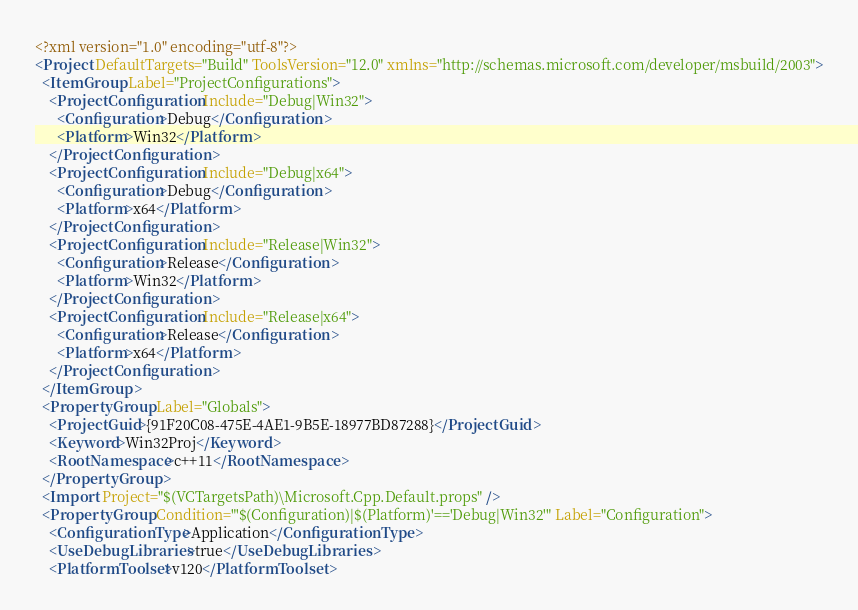Convert code to text. <code><loc_0><loc_0><loc_500><loc_500><_XML_><?xml version="1.0" encoding="utf-8"?>
<Project DefaultTargets="Build" ToolsVersion="12.0" xmlns="http://schemas.microsoft.com/developer/msbuild/2003">
  <ItemGroup Label="ProjectConfigurations">
    <ProjectConfiguration Include="Debug|Win32">
      <Configuration>Debug</Configuration>
      <Platform>Win32</Platform>
    </ProjectConfiguration>
    <ProjectConfiguration Include="Debug|x64">
      <Configuration>Debug</Configuration>
      <Platform>x64</Platform>
    </ProjectConfiguration>
    <ProjectConfiguration Include="Release|Win32">
      <Configuration>Release</Configuration>
      <Platform>Win32</Platform>
    </ProjectConfiguration>
    <ProjectConfiguration Include="Release|x64">
      <Configuration>Release</Configuration>
      <Platform>x64</Platform>
    </ProjectConfiguration>
  </ItemGroup>
  <PropertyGroup Label="Globals">
    <ProjectGuid>{91F20C08-475E-4AE1-9B5E-18977BD87288}</ProjectGuid>
    <Keyword>Win32Proj</Keyword>
    <RootNamespace>c++11</RootNamespace>
  </PropertyGroup>
  <Import Project="$(VCTargetsPath)\Microsoft.Cpp.Default.props" />
  <PropertyGroup Condition="'$(Configuration)|$(Platform)'=='Debug|Win32'" Label="Configuration">
    <ConfigurationType>Application</ConfigurationType>
    <UseDebugLibraries>true</UseDebugLibraries>
    <PlatformToolset>v120</PlatformToolset></code> 